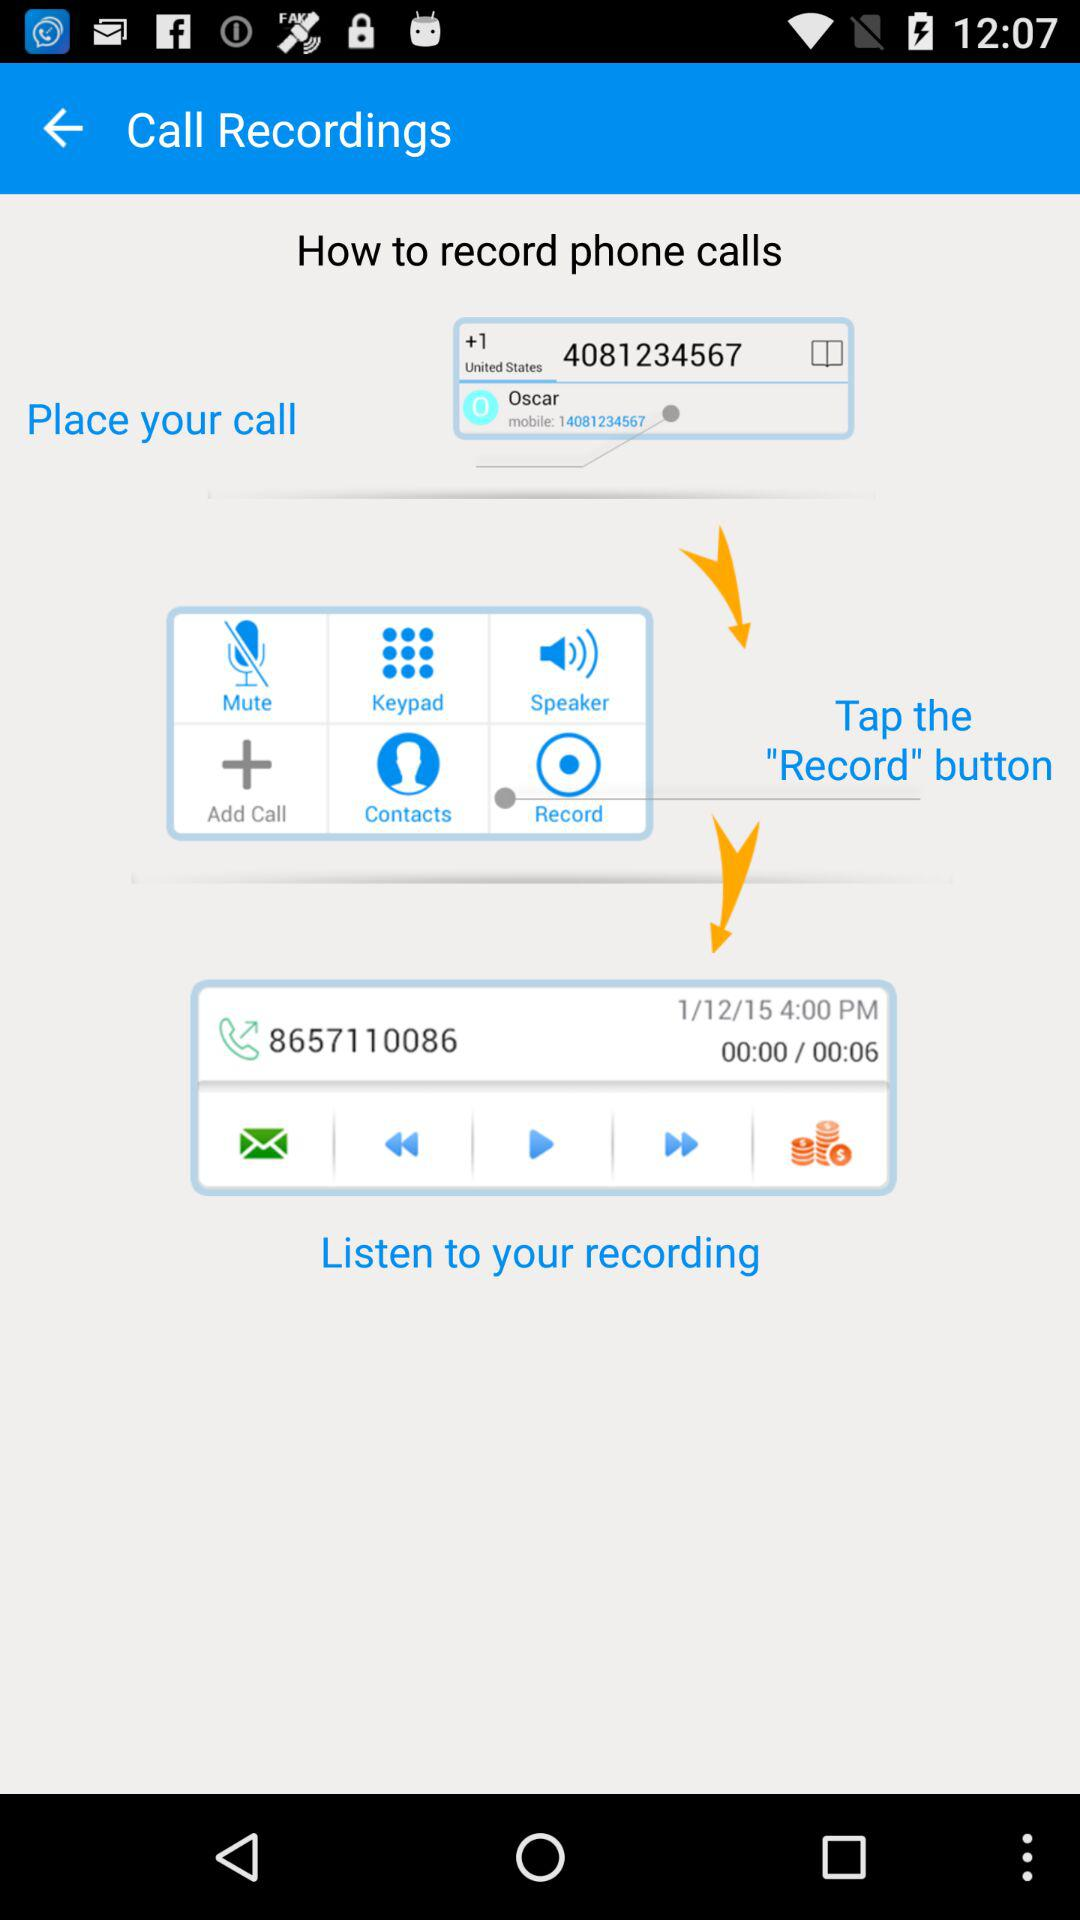How many more seconds are there in the recording than the time displayed?
Answer the question using a single word or phrase. 6 